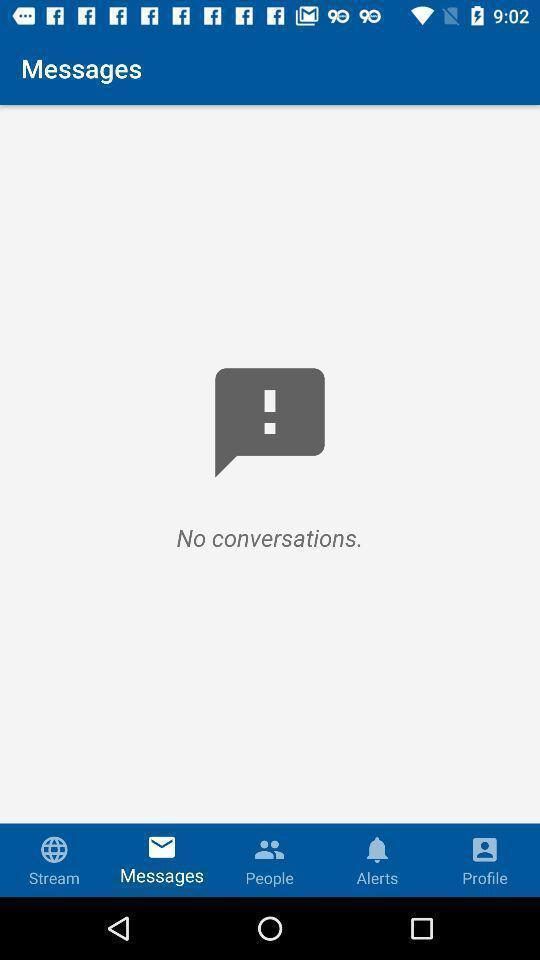Describe this image in words. Window displaying a messaging app. 